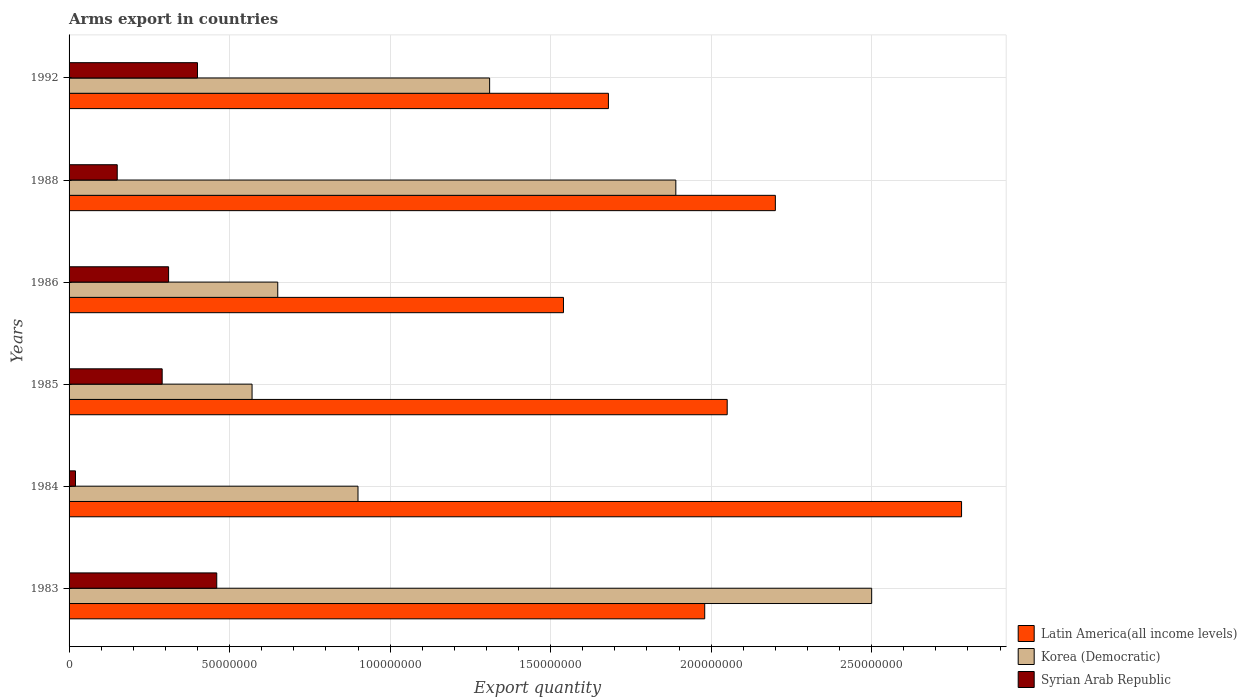How many groups of bars are there?
Keep it short and to the point. 6. How many bars are there on the 1st tick from the bottom?
Keep it short and to the point. 3. What is the total arms export in Korea (Democratic) in 1984?
Make the answer very short. 9.00e+07. Across all years, what is the maximum total arms export in Latin America(all income levels)?
Your response must be concise. 2.78e+08. Across all years, what is the minimum total arms export in Korea (Democratic)?
Keep it short and to the point. 5.70e+07. In which year was the total arms export in Syrian Arab Republic maximum?
Ensure brevity in your answer.  1983. In which year was the total arms export in Latin America(all income levels) minimum?
Offer a very short reply. 1986. What is the total total arms export in Latin America(all income levels) in the graph?
Offer a very short reply. 1.22e+09. What is the difference between the total arms export in Korea (Democratic) in 1986 and that in 1988?
Your answer should be compact. -1.24e+08. What is the difference between the total arms export in Syrian Arab Republic in 1992 and the total arms export in Latin America(all income levels) in 1985?
Your answer should be compact. -1.65e+08. What is the average total arms export in Korea (Democratic) per year?
Your response must be concise. 1.30e+08. In the year 1983, what is the difference between the total arms export in Latin America(all income levels) and total arms export in Syrian Arab Republic?
Provide a succinct answer. 1.52e+08. Is the total arms export in Korea (Democratic) in 1983 less than that in 1988?
Provide a short and direct response. No. What is the difference between the highest and the second highest total arms export in Syrian Arab Republic?
Your answer should be compact. 6.00e+06. What is the difference between the highest and the lowest total arms export in Latin America(all income levels)?
Your answer should be very brief. 1.24e+08. In how many years, is the total arms export in Syrian Arab Republic greater than the average total arms export in Syrian Arab Republic taken over all years?
Your response must be concise. 4. Is the sum of the total arms export in Korea (Democratic) in 1986 and 1988 greater than the maximum total arms export in Latin America(all income levels) across all years?
Make the answer very short. No. What does the 1st bar from the top in 1983 represents?
Keep it short and to the point. Syrian Arab Republic. What does the 1st bar from the bottom in 1992 represents?
Provide a short and direct response. Latin America(all income levels). Is it the case that in every year, the sum of the total arms export in Latin America(all income levels) and total arms export in Korea (Democratic) is greater than the total arms export in Syrian Arab Republic?
Provide a succinct answer. Yes. How many bars are there?
Your answer should be compact. 18. Are all the bars in the graph horizontal?
Ensure brevity in your answer.  Yes. Where does the legend appear in the graph?
Keep it short and to the point. Bottom right. How many legend labels are there?
Make the answer very short. 3. What is the title of the graph?
Your answer should be very brief. Arms export in countries. What is the label or title of the X-axis?
Offer a terse response. Export quantity. What is the Export quantity of Latin America(all income levels) in 1983?
Provide a short and direct response. 1.98e+08. What is the Export quantity of Korea (Democratic) in 1983?
Make the answer very short. 2.50e+08. What is the Export quantity of Syrian Arab Republic in 1983?
Your response must be concise. 4.60e+07. What is the Export quantity in Latin America(all income levels) in 1984?
Ensure brevity in your answer.  2.78e+08. What is the Export quantity of Korea (Democratic) in 1984?
Your answer should be compact. 9.00e+07. What is the Export quantity in Latin America(all income levels) in 1985?
Ensure brevity in your answer.  2.05e+08. What is the Export quantity in Korea (Democratic) in 1985?
Make the answer very short. 5.70e+07. What is the Export quantity in Syrian Arab Republic in 1985?
Give a very brief answer. 2.90e+07. What is the Export quantity of Latin America(all income levels) in 1986?
Your response must be concise. 1.54e+08. What is the Export quantity of Korea (Democratic) in 1986?
Ensure brevity in your answer.  6.50e+07. What is the Export quantity in Syrian Arab Republic in 1986?
Offer a very short reply. 3.10e+07. What is the Export quantity in Latin America(all income levels) in 1988?
Keep it short and to the point. 2.20e+08. What is the Export quantity of Korea (Democratic) in 1988?
Provide a short and direct response. 1.89e+08. What is the Export quantity in Syrian Arab Republic in 1988?
Ensure brevity in your answer.  1.50e+07. What is the Export quantity in Latin America(all income levels) in 1992?
Make the answer very short. 1.68e+08. What is the Export quantity of Korea (Democratic) in 1992?
Ensure brevity in your answer.  1.31e+08. What is the Export quantity in Syrian Arab Republic in 1992?
Your response must be concise. 4.00e+07. Across all years, what is the maximum Export quantity in Latin America(all income levels)?
Ensure brevity in your answer.  2.78e+08. Across all years, what is the maximum Export quantity in Korea (Democratic)?
Your answer should be very brief. 2.50e+08. Across all years, what is the maximum Export quantity in Syrian Arab Republic?
Keep it short and to the point. 4.60e+07. Across all years, what is the minimum Export quantity in Latin America(all income levels)?
Your answer should be very brief. 1.54e+08. Across all years, what is the minimum Export quantity in Korea (Democratic)?
Give a very brief answer. 5.70e+07. Across all years, what is the minimum Export quantity in Syrian Arab Republic?
Keep it short and to the point. 2.00e+06. What is the total Export quantity in Latin America(all income levels) in the graph?
Provide a short and direct response. 1.22e+09. What is the total Export quantity in Korea (Democratic) in the graph?
Offer a very short reply. 7.82e+08. What is the total Export quantity of Syrian Arab Republic in the graph?
Ensure brevity in your answer.  1.63e+08. What is the difference between the Export quantity of Latin America(all income levels) in 1983 and that in 1984?
Your answer should be very brief. -8.00e+07. What is the difference between the Export quantity in Korea (Democratic) in 1983 and that in 1984?
Your answer should be compact. 1.60e+08. What is the difference between the Export quantity in Syrian Arab Republic in 1983 and that in 1984?
Offer a very short reply. 4.40e+07. What is the difference between the Export quantity in Latin America(all income levels) in 1983 and that in 1985?
Make the answer very short. -7.00e+06. What is the difference between the Export quantity of Korea (Democratic) in 1983 and that in 1985?
Make the answer very short. 1.93e+08. What is the difference between the Export quantity of Syrian Arab Republic in 1983 and that in 1985?
Offer a very short reply. 1.70e+07. What is the difference between the Export quantity of Latin America(all income levels) in 1983 and that in 1986?
Make the answer very short. 4.40e+07. What is the difference between the Export quantity of Korea (Democratic) in 1983 and that in 1986?
Your answer should be compact. 1.85e+08. What is the difference between the Export quantity of Syrian Arab Republic in 1983 and that in 1986?
Provide a short and direct response. 1.50e+07. What is the difference between the Export quantity in Latin America(all income levels) in 1983 and that in 1988?
Give a very brief answer. -2.20e+07. What is the difference between the Export quantity of Korea (Democratic) in 1983 and that in 1988?
Your answer should be very brief. 6.10e+07. What is the difference between the Export quantity of Syrian Arab Republic in 1983 and that in 1988?
Provide a short and direct response. 3.10e+07. What is the difference between the Export quantity of Latin America(all income levels) in 1983 and that in 1992?
Your response must be concise. 3.00e+07. What is the difference between the Export quantity in Korea (Democratic) in 1983 and that in 1992?
Your response must be concise. 1.19e+08. What is the difference between the Export quantity in Latin America(all income levels) in 1984 and that in 1985?
Your answer should be compact. 7.30e+07. What is the difference between the Export quantity in Korea (Democratic) in 1984 and that in 1985?
Give a very brief answer. 3.30e+07. What is the difference between the Export quantity in Syrian Arab Republic in 1984 and that in 1985?
Your answer should be compact. -2.70e+07. What is the difference between the Export quantity in Latin America(all income levels) in 1984 and that in 1986?
Provide a short and direct response. 1.24e+08. What is the difference between the Export quantity in Korea (Democratic) in 1984 and that in 1986?
Give a very brief answer. 2.50e+07. What is the difference between the Export quantity in Syrian Arab Republic in 1984 and that in 1986?
Offer a very short reply. -2.90e+07. What is the difference between the Export quantity in Latin America(all income levels) in 1984 and that in 1988?
Your response must be concise. 5.80e+07. What is the difference between the Export quantity in Korea (Democratic) in 1984 and that in 1988?
Your answer should be compact. -9.90e+07. What is the difference between the Export quantity in Syrian Arab Republic in 1984 and that in 1988?
Keep it short and to the point. -1.30e+07. What is the difference between the Export quantity in Latin America(all income levels) in 1984 and that in 1992?
Offer a terse response. 1.10e+08. What is the difference between the Export quantity in Korea (Democratic) in 1984 and that in 1992?
Offer a very short reply. -4.10e+07. What is the difference between the Export quantity of Syrian Arab Republic in 1984 and that in 1992?
Offer a terse response. -3.80e+07. What is the difference between the Export quantity in Latin America(all income levels) in 1985 and that in 1986?
Ensure brevity in your answer.  5.10e+07. What is the difference between the Export quantity in Korea (Democratic) in 1985 and that in 1986?
Ensure brevity in your answer.  -8.00e+06. What is the difference between the Export quantity in Latin America(all income levels) in 1985 and that in 1988?
Give a very brief answer. -1.50e+07. What is the difference between the Export quantity in Korea (Democratic) in 1985 and that in 1988?
Give a very brief answer. -1.32e+08. What is the difference between the Export quantity in Syrian Arab Republic in 1985 and that in 1988?
Ensure brevity in your answer.  1.40e+07. What is the difference between the Export quantity of Latin America(all income levels) in 1985 and that in 1992?
Your response must be concise. 3.70e+07. What is the difference between the Export quantity of Korea (Democratic) in 1985 and that in 1992?
Ensure brevity in your answer.  -7.40e+07. What is the difference between the Export quantity of Syrian Arab Republic in 1985 and that in 1992?
Your answer should be compact. -1.10e+07. What is the difference between the Export quantity in Latin America(all income levels) in 1986 and that in 1988?
Offer a very short reply. -6.60e+07. What is the difference between the Export quantity in Korea (Democratic) in 1986 and that in 1988?
Your answer should be compact. -1.24e+08. What is the difference between the Export quantity of Syrian Arab Republic in 1986 and that in 1988?
Give a very brief answer. 1.60e+07. What is the difference between the Export quantity in Latin America(all income levels) in 1986 and that in 1992?
Keep it short and to the point. -1.40e+07. What is the difference between the Export quantity of Korea (Democratic) in 1986 and that in 1992?
Offer a very short reply. -6.60e+07. What is the difference between the Export quantity of Syrian Arab Republic in 1986 and that in 1992?
Ensure brevity in your answer.  -9.00e+06. What is the difference between the Export quantity in Latin America(all income levels) in 1988 and that in 1992?
Ensure brevity in your answer.  5.20e+07. What is the difference between the Export quantity in Korea (Democratic) in 1988 and that in 1992?
Make the answer very short. 5.80e+07. What is the difference between the Export quantity in Syrian Arab Republic in 1988 and that in 1992?
Provide a succinct answer. -2.50e+07. What is the difference between the Export quantity in Latin America(all income levels) in 1983 and the Export quantity in Korea (Democratic) in 1984?
Make the answer very short. 1.08e+08. What is the difference between the Export quantity of Latin America(all income levels) in 1983 and the Export quantity of Syrian Arab Republic in 1984?
Offer a terse response. 1.96e+08. What is the difference between the Export quantity in Korea (Democratic) in 1983 and the Export quantity in Syrian Arab Republic in 1984?
Make the answer very short. 2.48e+08. What is the difference between the Export quantity of Latin America(all income levels) in 1983 and the Export quantity of Korea (Democratic) in 1985?
Ensure brevity in your answer.  1.41e+08. What is the difference between the Export quantity in Latin America(all income levels) in 1983 and the Export quantity in Syrian Arab Republic in 1985?
Ensure brevity in your answer.  1.69e+08. What is the difference between the Export quantity of Korea (Democratic) in 1983 and the Export quantity of Syrian Arab Republic in 1985?
Keep it short and to the point. 2.21e+08. What is the difference between the Export quantity of Latin America(all income levels) in 1983 and the Export quantity of Korea (Democratic) in 1986?
Your answer should be compact. 1.33e+08. What is the difference between the Export quantity in Latin America(all income levels) in 1983 and the Export quantity in Syrian Arab Republic in 1986?
Offer a terse response. 1.67e+08. What is the difference between the Export quantity of Korea (Democratic) in 1983 and the Export quantity of Syrian Arab Republic in 1986?
Provide a succinct answer. 2.19e+08. What is the difference between the Export quantity in Latin America(all income levels) in 1983 and the Export quantity in Korea (Democratic) in 1988?
Your answer should be very brief. 9.00e+06. What is the difference between the Export quantity of Latin America(all income levels) in 1983 and the Export quantity of Syrian Arab Republic in 1988?
Your answer should be very brief. 1.83e+08. What is the difference between the Export quantity in Korea (Democratic) in 1983 and the Export quantity in Syrian Arab Republic in 1988?
Keep it short and to the point. 2.35e+08. What is the difference between the Export quantity of Latin America(all income levels) in 1983 and the Export quantity of Korea (Democratic) in 1992?
Offer a very short reply. 6.70e+07. What is the difference between the Export quantity of Latin America(all income levels) in 1983 and the Export quantity of Syrian Arab Republic in 1992?
Make the answer very short. 1.58e+08. What is the difference between the Export quantity in Korea (Democratic) in 1983 and the Export quantity in Syrian Arab Republic in 1992?
Your response must be concise. 2.10e+08. What is the difference between the Export quantity of Latin America(all income levels) in 1984 and the Export quantity of Korea (Democratic) in 1985?
Provide a succinct answer. 2.21e+08. What is the difference between the Export quantity of Latin America(all income levels) in 1984 and the Export quantity of Syrian Arab Republic in 1985?
Offer a terse response. 2.49e+08. What is the difference between the Export quantity of Korea (Democratic) in 1984 and the Export quantity of Syrian Arab Republic in 1985?
Make the answer very short. 6.10e+07. What is the difference between the Export quantity of Latin America(all income levels) in 1984 and the Export quantity of Korea (Democratic) in 1986?
Offer a terse response. 2.13e+08. What is the difference between the Export quantity in Latin America(all income levels) in 1984 and the Export quantity in Syrian Arab Republic in 1986?
Offer a very short reply. 2.47e+08. What is the difference between the Export quantity in Korea (Democratic) in 1984 and the Export quantity in Syrian Arab Republic in 1986?
Your response must be concise. 5.90e+07. What is the difference between the Export quantity in Latin America(all income levels) in 1984 and the Export quantity in Korea (Democratic) in 1988?
Your answer should be compact. 8.90e+07. What is the difference between the Export quantity in Latin America(all income levels) in 1984 and the Export quantity in Syrian Arab Republic in 1988?
Provide a succinct answer. 2.63e+08. What is the difference between the Export quantity in Korea (Democratic) in 1984 and the Export quantity in Syrian Arab Republic in 1988?
Offer a very short reply. 7.50e+07. What is the difference between the Export quantity in Latin America(all income levels) in 1984 and the Export quantity in Korea (Democratic) in 1992?
Your answer should be compact. 1.47e+08. What is the difference between the Export quantity in Latin America(all income levels) in 1984 and the Export quantity in Syrian Arab Republic in 1992?
Make the answer very short. 2.38e+08. What is the difference between the Export quantity of Latin America(all income levels) in 1985 and the Export quantity of Korea (Democratic) in 1986?
Give a very brief answer. 1.40e+08. What is the difference between the Export quantity in Latin America(all income levels) in 1985 and the Export quantity in Syrian Arab Republic in 1986?
Make the answer very short. 1.74e+08. What is the difference between the Export quantity of Korea (Democratic) in 1985 and the Export quantity of Syrian Arab Republic in 1986?
Offer a very short reply. 2.60e+07. What is the difference between the Export quantity in Latin America(all income levels) in 1985 and the Export quantity in Korea (Democratic) in 1988?
Provide a short and direct response. 1.60e+07. What is the difference between the Export quantity of Latin America(all income levels) in 1985 and the Export quantity of Syrian Arab Republic in 1988?
Offer a very short reply. 1.90e+08. What is the difference between the Export quantity in Korea (Democratic) in 1985 and the Export quantity in Syrian Arab Republic in 1988?
Provide a succinct answer. 4.20e+07. What is the difference between the Export quantity in Latin America(all income levels) in 1985 and the Export quantity in Korea (Democratic) in 1992?
Offer a very short reply. 7.40e+07. What is the difference between the Export quantity of Latin America(all income levels) in 1985 and the Export quantity of Syrian Arab Republic in 1992?
Your response must be concise. 1.65e+08. What is the difference between the Export quantity in Korea (Democratic) in 1985 and the Export quantity in Syrian Arab Republic in 1992?
Your response must be concise. 1.70e+07. What is the difference between the Export quantity in Latin America(all income levels) in 1986 and the Export quantity in Korea (Democratic) in 1988?
Provide a short and direct response. -3.50e+07. What is the difference between the Export quantity in Latin America(all income levels) in 1986 and the Export quantity in Syrian Arab Republic in 1988?
Your answer should be compact. 1.39e+08. What is the difference between the Export quantity of Korea (Democratic) in 1986 and the Export quantity of Syrian Arab Republic in 1988?
Your answer should be compact. 5.00e+07. What is the difference between the Export quantity of Latin America(all income levels) in 1986 and the Export quantity of Korea (Democratic) in 1992?
Provide a short and direct response. 2.30e+07. What is the difference between the Export quantity in Latin America(all income levels) in 1986 and the Export quantity in Syrian Arab Republic in 1992?
Give a very brief answer. 1.14e+08. What is the difference between the Export quantity in Korea (Democratic) in 1986 and the Export quantity in Syrian Arab Republic in 1992?
Offer a terse response. 2.50e+07. What is the difference between the Export quantity in Latin America(all income levels) in 1988 and the Export quantity in Korea (Democratic) in 1992?
Provide a short and direct response. 8.90e+07. What is the difference between the Export quantity in Latin America(all income levels) in 1988 and the Export quantity in Syrian Arab Republic in 1992?
Give a very brief answer. 1.80e+08. What is the difference between the Export quantity in Korea (Democratic) in 1988 and the Export quantity in Syrian Arab Republic in 1992?
Provide a succinct answer. 1.49e+08. What is the average Export quantity of Latin America(all income levels) per year?
Ensure brevity in your answer.  2.04e+08. What is the average Export quantity in Korea (Democratic) per year?
Offer a terse response. 1.30e+08. What is the average Export quantity of Syrian Arab Republic per year?
Make the answer very short. 2.72e+07. In the year 1983, what is the difference between the Export quantity in Latin America(all income levels) and Export quantity in Korea (Democratic)?
Your answer should be compact. -5.20e+07. In the year 1983, what is the difference between the Export quantity of Latin America(all income levels) and Export quantity of Syrian Arab Republic?
Make the answer very short. 1.52e+08. In the year 1983, what is the difference between the Export quantity of Korea (Democratic) and Export quantity of Syrian Arab Republic?
Your response must be concise. 2.04e+08. In the year 1984, what is the difference between the Export quantity in Latin America(all income levels) and Export quantity in Korea (Democratic)?
Ensure brevity in your answer.  1.88e+08. In the year 1984, what is the difference between the Export quantity in Latin America(all income levels) and Export quantity in Syrian Arab Republic?
Provide a succinct answer. 2.76e+08. In the year 1984, what is the difference between the Export quantity in Korea (Democratic) and Export quantity in Syrian Arab Republic?
Provide a short and direct response. 8.80e+07. In the year 1985, what is the difference between the Export quantity of Latin America(all income levels) and Export quantity of Korea (Democratic)?
Ensure brevity in your answer.  1.48e+08. In the year 1985, what is the difference between the Export quantity of Latin America(all income levels) and Export quantity of Syrian Arab Republic?
Your answer should be very brief. 1.76e+08. In the year 1985, what is the difference between the Export quantity in Korea (Democratic) and Export quantity in Syrian Arab Republic?
Provide a short and direct response. 2.80e+07. In the year 1986, what is the difference between the Export quantity in Latin America(all income levels) and Export quantity in Korea (Democratic)?
Ensure brevity in your answer.  8.90e+07. In the year 1986, what is the difference between the Export quantity of Latin America(all income levels) and Export quantity of Syrian Arab Republic?
Offer a terse response. 1.23e+08. In the year 1986, what is the difference between the Export quantity of Korea (Democratic) and Export quantity of Syrian Arab Republic?
Make the answer very short. 3.40e+07. In the year 1988, what is the difference between the Export quantity in Latin America(all income levels) and Export quantity in Korea (Democratic)?
Your answer should be very brief. 3.10e+07. In the year 1988, what is the difference between the Export quantity in Latin America(all income levels) and Export quantity in Syrian Arab Republic?
Provide a succinct answer. 2.05e+08. In the year 1988, what is the difference between the Export quantity in Korea (Democratic) and Export quantity in Syrian Arab Republic?
Your answer should be compact. 1.74e+08. In the year 1992, what is the difference between the Export quantity of Latin America(all income levels) and Export quantity of Korea (Democratic)?
Your answer should be very brief. 3.70e+07. In the year 1992, what is the difference between the Export quantity of Latin America(all income levels) and Export quantity of Syrian Arab Republic?
Your answer should be very brief. 1.28e+08. In the year 1992, what is the difference between the Export quantity in Korea (Democratic) and Export quantity in Syrian Arab Republic?
Provide a short and direct response. 9.10e+07. What is the ratio of the Export quantity in Latin America(all income levels) in 1983 to that in 1984?
Make the answer very short. 0.71. What is the ratio of the Export quantity of Korea (Democratic) in 1983 to that in 1984?
Give a very brief answer. 2.78. What is the ratio of the Export quantity in Syrian Arab Republic in 1983 to that in 1984?
Offer a terse response. 23. What is the ratio of the Export quantity in Latin America(all income levels) in 1983 to that in 1985?
Offer a very short reply. 0.97. What is the ratio of the Export quantity of Korea (Democratic) in 1983 to that in 1985?
Provide a succinct answer. 4.39. What is the ratio of the Export quantity in Syrian Arab Republic in 1983 to that in 1985?
Your answer should be compact. 1.59. What is the ratio of the Export quantity in Latin America(all income levels) in 1983 to that in 1986?
Make the answer very short. 1.29. What is the ratio of the Export quantity in Korea (Democratic) in 1983 to that in 1986?
Make the answer very short. 3.85. What is the ratio of the Export quantity of Syrian Arab Republic in 1983 to that in 1986?
Offer a terse response. 1.48. What is the ratio of the Export quantity of Korea (Democratic) in 1983 to that in 1988?
Offer a terse response. 1.32. What is the ratio of the Export quantity in Syrian Arab Republic in 1983 to that in 1988?
Give a very brief answer. 3.07. What is the ratio of the Export quantity in Latin America(all income levels) in 1983 to that in 1992?
Provide a succinct answer. 1.18. What is the ratio of the Export quantity in Korea (Democratic) in 1983 to that in 1992?
Provide a succinct answer. 1.91. What is the ratio of the Export quantity in Syrian Arab Republic in 1983 to that in 1992?
Make the answer very short. 1.15. What is the ratio of the Export quantity of Latin America(all income levels) in 1984 to that in 1985?
Offer a very short reply. 1.36. What is the ratio of the Export quantity in Korea (Democratic) in 1984 to that in 1985?
Provide a short and direct response. 1.58. What is the ratio of the Export quantity of Syrian Arab Republic in 1984 to that in 1985?
Offer a very short reply. 0.07. What is the ratio of the Export quantity in Latin America(all income levels) in 1984 to that in 1986?
Offer a terse response. 1.81. What is the ratio of the Export quantity in Korea (Democratic) in 1984 to that in 1986?
Provide a succinct answer. 1.38. What is the ratio of the Export quantity of Syrian Arab Republic in 1984 to that in 1986?
Your answer should be very brief. 0.06. What is the ratio of the Export quantity in Latin America(all income levels) in 1984 to that in 1988?
Provide a succinct answer. 1.26. What is the ratio of the Export quantity in Korea (Democratic) in 1984 to that in 1988?
Make the answer very short. 0.48. What is the ratio of the Export quantity in Syrian Arab Republic in 1984 to that in 1988?
Offer a terse response. 0.13. What is the ratio of the Export quantity in Latin America(all income levels) in 1984 to that in 1992?
Ensure brevity in your answer.  1.65. What is the ratio of the Export quantity of Korea (Democratic) in 1984 to that in 1992?
Ensure brevity in your answer.  0.69. What is the ratio of the Export quantity of Latin America(all income levels) in 1985 to that in 1986?
Your answer should be very brief. 1.33. What is the ratio of the Export quantity in Korea (Democratic) in 1985 to that in 1986?
Provide a succinct answer. 0.88. What is the ratio of the Export quantity of Syrian Arab Republic in 1985 to that in 1986?
Make the answer very short. 0.94. What is the ratio of the Export quantity in Latin America(all income levels) in 1985 to that in 1988?
Provide a succinct answer. 0.93. What is the ratio of the Export quantity in Korea (Democratic) in 1985 to that in 1988?
Make the answer very short. 0.3. What is the ratio of the Export quantity in Syrian Arab Republic in 1985 to that in 1988?
Offer a terse response. 1.93. What is the ratio of the Export quantity in Latin America(all income levels) in 1985 to that in 1992?
Give a very brief answer. 1.22. What is the ratio of the Export quantity of Korea (Democratic) in 1985 to that in 1992?
Give a very brief answer. 0.44. What is the ratio of the Export quantity of Syrian Arab Republic in 1985 to that in 1992?
Make the answer very short. 0.72. What is the ratio of the Export quantity in Latin America(all income levels) in 1986 to that in 1988?
Your answer should be compact. 0.7. What is the ratio of the Export quantity in Korea (Democratic) in 1986 to that in 1988?
Ensure brevity in your answer.  0.34. What is the ratio of the Export quantity of Syrian Arab Republic in 1986 to that in 1988?
Your answer should be compact. 2.07. What is the ratio of the Export quantity in Korea (Democratic) in 1986 to that in 1992?
Your answer should be compact. 0.5. What is the ratio of the Export quantity in Syrian Arab Republic in 1986 to that in 1992?
Provide a short and direct response. 0.78. What is the ratio of the Export quantity of Latin America(all income levels) in 1988 to that in 1992?
Keep it short and to the point. 1.31. What is the ratio of the Export quantity of Korea (Democratic) in 1988 to that in 1992?
Offer a very short reply. 1.44. What is the difference between the highest and the second highest Export quantity of Latin America(all income levels)?
Offer a terse response. 5.80e+07. What is the difference between the highest and the second highest Export quantity in Korea (Democratic)?
Provide a succinct answer. 6.10e+07. What is the difference between the highest and the lowest Export quantity in Latin America(all income levels)?
Offer a very short reply. 1.24e+08. What is the difference between the highest and the lowest Export quantity of Korea (Democratic)?
Provide a succinct answer. 1.93e+08. What is the difference between the highest and the lowest Export quantity of Syrian Arab Republic?
Provide a short and direct response. 4.40e+07. 